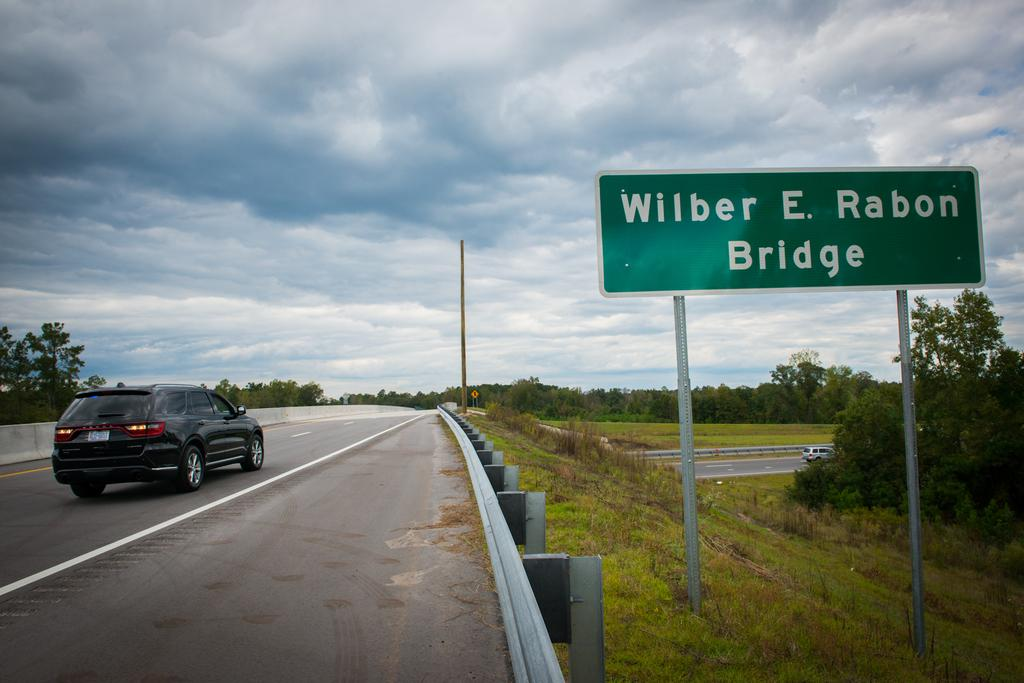What type of vehicle can be seen on the road in the image? There is a car on the road in the image. What type of vegetation is visible in the image? There is grass visible in the image. What object can be seen in the image that might be used for displaying information or advertisements? There is a board in the image. What type of natural structures are present in the image? There are trees in the image. What type of barrier can be seen in the image? There is a fence in the image. Are there any other vehicles visible in the image? Yes, there is another car on the road in the image. What type of vertical structure can be seen in the image? There is a pole in the image. What is visible in the sky in the image? The sky is visible in the image, and it appears cloudy. How many friends are sitting on the car in the image? There are no friends sitting on the car in the image. What type of clothing is hanging on the pole in the image? There is no clothing hanging on the pole in the image. 